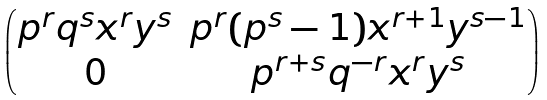Convert formula to latex. <formula><loc_0><loc_0><loc_500><loc_500>\begin{pmatrix} p ^ { r } q ^ { s } x ^ { r } y ^ { s } & p ^ { r } ( p ^ { s } - 1 ) x ^ { r + 1 } y ^ { s - 1 } \\ 0 & p ^ { r + s } q ^ { - r } x ^ { r } y ^ { s } \end{pmatrix}</formula> 